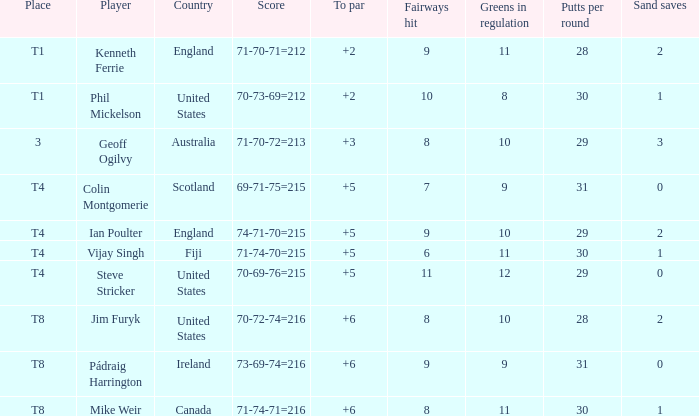Could you help me parse every detail presented in this table? {'header': ['Place', 'Player', 'Country', 'Score', 'To par', 'Fairways hit', 'Greens in regulation', 'Putts per round', 'Sand saves'], 'rows': [['T1', 'Kenneth Ferrie', 'England', '71-70-71=212', '+2', '9', '11', '28', '2'], ['T1', 'Phil Mickelson', 'United States', '70-73-69=212', '+2', '10', '8', '30', '1'], ['3', 'Geoff Ogilvy', 'Australia', '71-70-72=213', '+3', '8', '10', '29', '3'], ['T4', 'Colin Montgomerie', 'Scotland', '69-71-75=215', '+5', '7', '9', '31', '0'], ['T4', 'Ian Poulter', 'England', '74-71-70=215', '+5', '9', '10', '29', '2'], ['T4', 'Vijay Singh', 'Fiji', '71-74-70=215', '+5', '6', '11', '30', '1'], ['T4', 'Steve Stricker', 'United States', '70-69-76=215', '+5', '11', '12', '29', '0'], ['T8', 'Jim Furyk', 'United States', '70-72-74=216', '+6', '8', '10', '28', '2'], ['T8', 'Pádraig Harrington', 'Ireland', '73-69-74=216', '+6', '9', '9', '31', '0'], ['T8', 'Mike Weir', 'Canada', '71-74-71=216', '+6', '8', '11', '30', '1']]} Who had a score of 70-73-69=212? Phil Mickelson. 